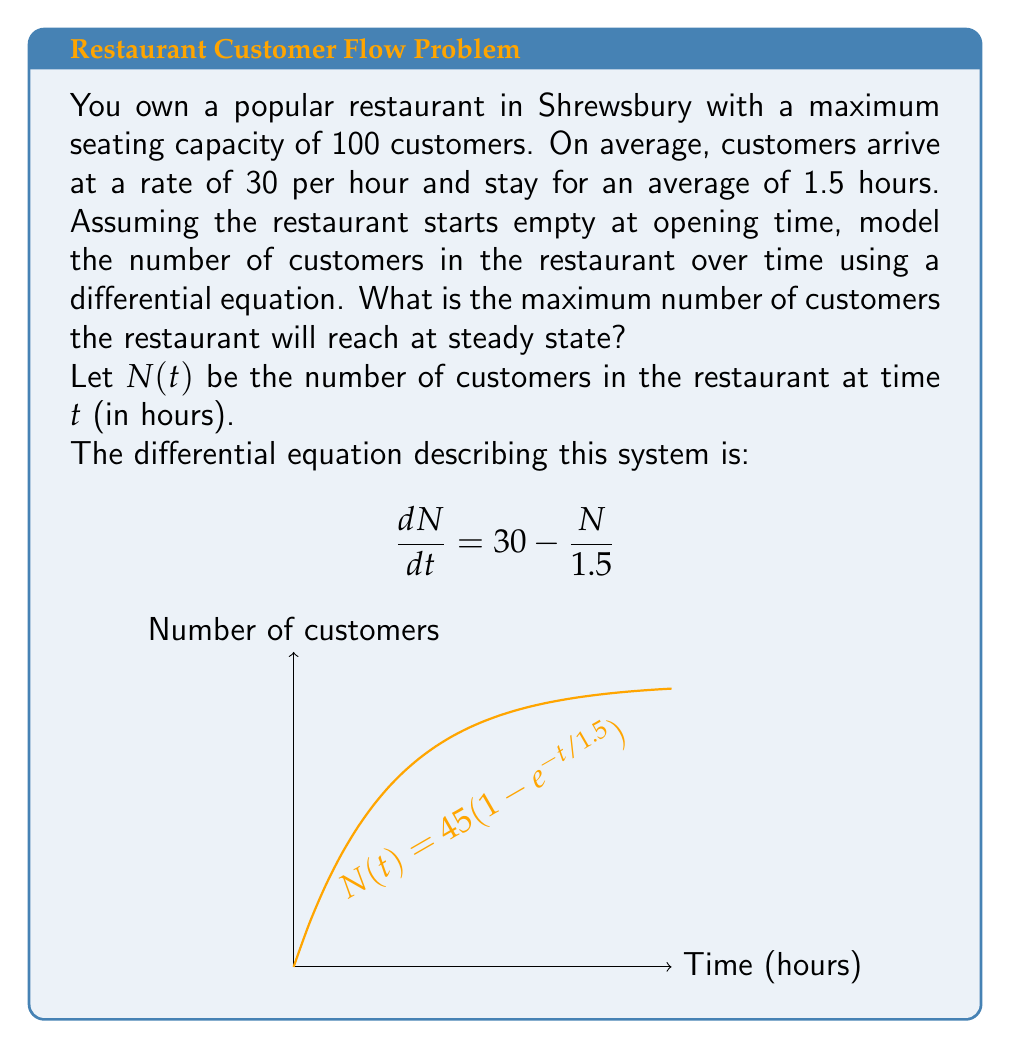Solve this math problem. To solve this problem, we'll follow these steps:

1) First, let's understand the differential equation:
   $$\frac{dN}{dt} = 30 - \frac{N}{1.5}$$
   - 30 represents the arrival rate (customers/hour)
   - $\frac{N}{1.5}$ represents the departure rate (customers/hour)

2) To find the steady state, we set $\frac{dN}{dt} = 0$:
   $$0 = 30 - \frac{N}{1.5}$$

3) Solve for $N$:
   $$\frac{N}{1.5} = 30$$
   $$N = 30 * 1.5 = 45$$

4) Therefore, at steady state, the restaurant will have 45 customers.

5) To verify this is the maximum:
   - When $N < 45$, $\frac{dN}{dt} > 0$, so $N$ increases
   - When $N > 45$, $\frac{dN}{dt} < 0$, so $N$ decreases
   - Thus, 45 is a stable equilibrium and the maximum number of customers

6) The full solution to the differential equation is:
   $$N(t) = 45(1-e^{-t/1.5})$$
   This approaches 45 as $t$ approaches infinity, confirming our steady-state result.
Answer: 45 customers 